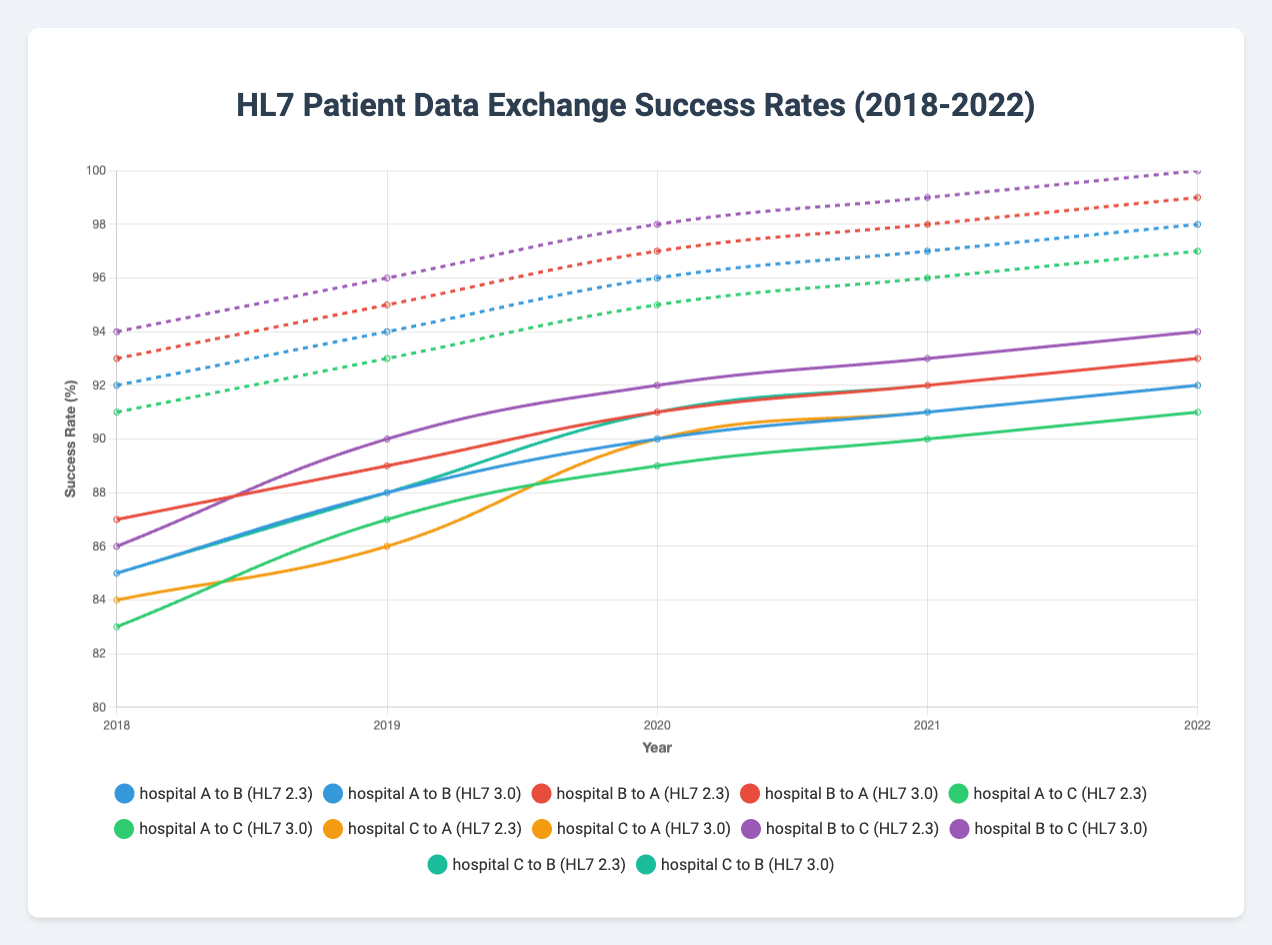What is the highest success rate for hospital data exchange in 2022? To determine the highest success rate in 2022, we see both versions of HL7 across all hospital pairs. Reviewing the plot for 2022, identify the highest data point. The highest rate is observed in the HL7 3.0 versions, and specifically for the pair "hospital_B_to_C," which achieves a 100% success rate.
Answer: 100 Which hospital pair had the lowest success rate in 2018 using HL7 version 2.3? For 2018 with HL7 version 2.3, check the success rates for each hospital pair: hospital_A_to_B (85%), hospital_B_to_A (87%), hospital_A_to_C (83%), hospital_C_to_A (84%), hospital_B_to_C (86%), hospital_C_to_B (85%). The lowest rate is for hospital_A_to_C at 83%.
Answer: Hospital A to C How did the success rates for hospital_B_to_A change from 2018 to 2019 using HL7 2.3? For HL7 2.3, examine hospital_B_to_A’s success rates for 2018 (87%) and 2019 (89%). The change is 89% - 87% = 2%, showing an increase.
Answer: Increased by 2% Compare the average success rates of all hospital pairs in 2019 using HL7 2.3 and 3.0 For 2019, calculate the average success rate for HL7 2.3: (88 + 89 + 87 + 86 + 90 + 88) / 6 = 88%. Then for 3.0: (94 + 95 + 93 + 94 + 96 + 95) / 6 = 94.5%. Thus, the averages differ.
Answer: 88% for HL7 2.3, 94.5% for HL7 3.0 Which HL7 version shows a more significant improvement in exchange success rates from 2018 to 2022? Calculate the average success rate over all hospital pairs for 2018, and 2022, and compare the two. For HL7 2.3: 2018 (85+87+83+84+86+85)/6 = 85% -> 2022 (92+93+91+92+94+93)/6 = 92.5%. For HL7 3.0: 2018 (92+93+91+92+94+93)/6 = 92.5% -> 2022 (98+99+97+98+100+99)/6 = 98.5%. HL7 3.0 shows a greater improvement (6%).
Answer: HL7 3.0 Which hospital pair had the most consistent (least varying) success rates between 2018 and 2022 using HL7 version 2.3? Calculate the range (difference between the highest and lowest values) for each hospital pair using HL7 2.3 from 2018 to 2022. Lower range indicates more consistency. For hospital_A_to_B: (92-85)=7%, hospital_B_to_A: (93-87)=6%, hospital_A_to_C: (91-83)=8%, hospital_C_to_A: (92-84)=8%, hospital_B_to_C: (94-86)=8%, hospital_C_to_B: (93-85)=8%. Hospital_B_to_A is the most consistent.
Answer: Hospital B to A What is the average success rate for hospital_A_to_C across the five years using HL7 3.0? Average the success rates for hospital_A_to_C using HL7 3.0: (91+93+95+96+97)/5 = 94.4%.
Answer: 94.4% Did any hospital pairs ever reach a 100% success rate using HL7 2.3 from 2018 to 2022? Review all the data points for any hospital pair using HL7 2.3 from 2018 to 2022. None of the hospital pairs achieved a 100% success rate.
Answer: No Is there a year where all hospital pairs using HL7 3.0 have a higher success rate than any pair using HL7 2.3? Check each year comparing the highest HL7 2.3 rates to the lowest HL7 3.0 rates. In 2022, all HL7 3.0 pairs have higher success rates (97-100%) than any HL7 2.3 pairs (91-94%).
Answer: Yes, 2022 